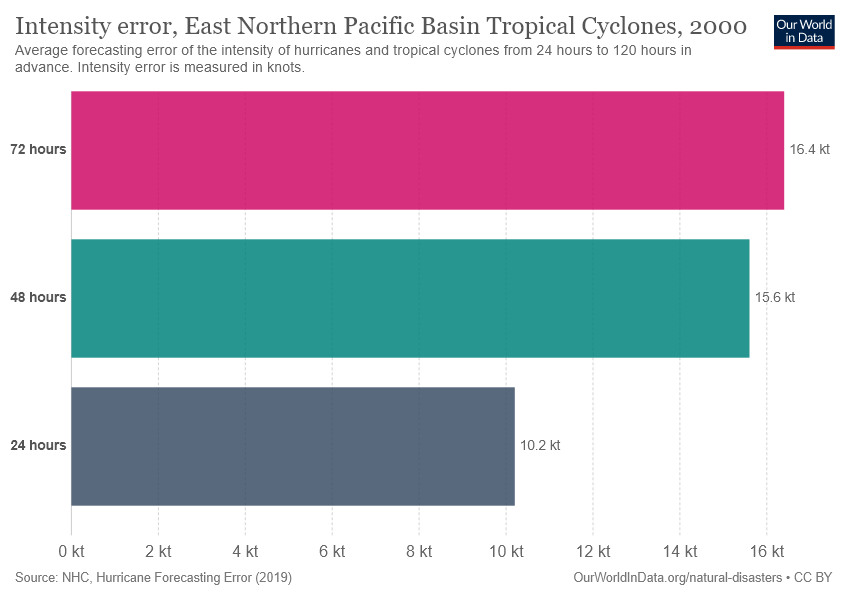Outline some significant characteristics in this image. The sum of all measures of intensity error is 42.2. The measured intensity error was 10.2 in a 24-hour period. 